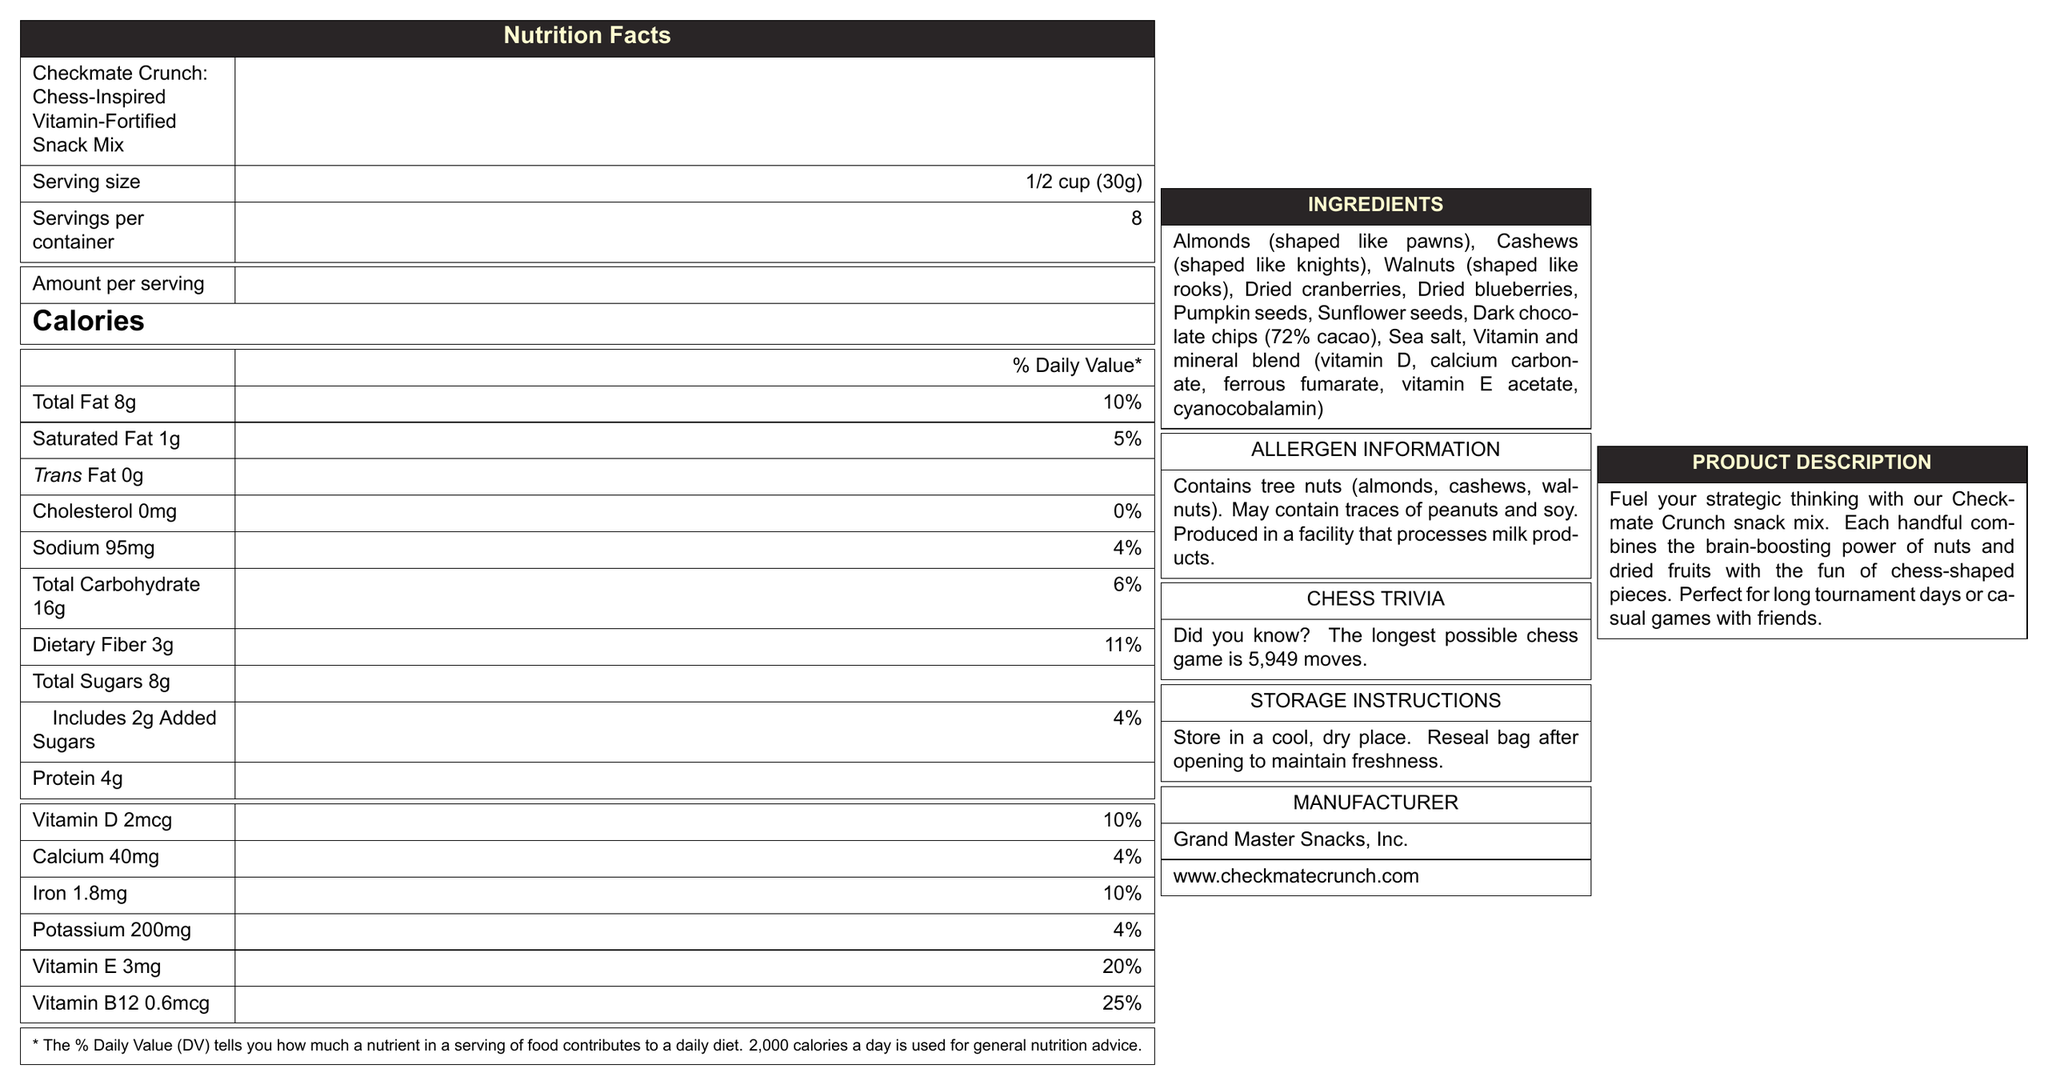what is the serving size? The serving size is listed as "1/2 cup (30g)" in the document.
Answer: 1/2 cup (30g) how many calories are in one serving? The number of calories per serving is specified as "140" in the document.
Answer: 140 how much total fat is in one serving (in grams)? The amount of total fat is given as "8g" per serving in the document.
Answer: 8g what percentage of the daily value is the saturated fat content? The saturated fat content is listed as having a daily value percentage of "5%" in the document.
Answer: 5% how many servings are there per container? The number of servings per container is stated as "8" in the document.
Answer: 8 which type of nuts are shaped like pawns? The ingredient list specifies that almonds are "shaped like pawns."
Answer: Almonds what is the daily value percentage of vitamin B12 provided in one serving? The document indicates that the daily value percentage for vitamin B12 is "25%."
Answer: 25% which of the following vitamins is present in the greatest daily value percentage: A. Vitamin D B. Calcium C. Iron D. Vitamin E E. Vitamin B12 The document shows that vitamin B12 has a daily value percentage of "25%," which is the highest among the listed options.
Answer: E. Vitamin B12 which ingredient is not mentioned in the snack mix? A. Dried cranberries B. Almonds C. Peanuts D. Pumpkin seeds Peanuts are not listed as an ingredient in the snack mix.
Answer: C. Peanuts how many grams of dietary fiber are there in one serving? A. 4g B. 3g C. 2g D. 5g The document states that dietary fiber is "3g" per serving.
Answer: B. 3g does the product contain milk products? The allergen information states that the product is produced in a facility that processes milk products, but it does not contain milk products itself.
Answer: No summarize the main idea of this document. The content of the document is structured to give a complete overview of the snack mix, from nutrition and ingredients to manufacturing and additional information, aimed at providing consumers with all necessary details.
Answer: The document provides detailed information on the nutritional facts, ingredients, allergen information, and storage instructions for the product "Checkmate Crunch: Chess-Inspired Vitamin-Fortified Snack Mix." It includes a product description emphasizing its brain-boosting benefits and chess-themed fun, as well as manufacturing details and a piece of chess trivia. what is the manufacturer's website? The document lists the manufacturer's website as "www.checkmatecrunch.com."
Answer: www.checkmatecrunch.com is the document prepared using LaTeX? The document itself does not contain any information about whether it was prepared using LaTeX or any other specific typesetting system.
Answer: Not enough information 